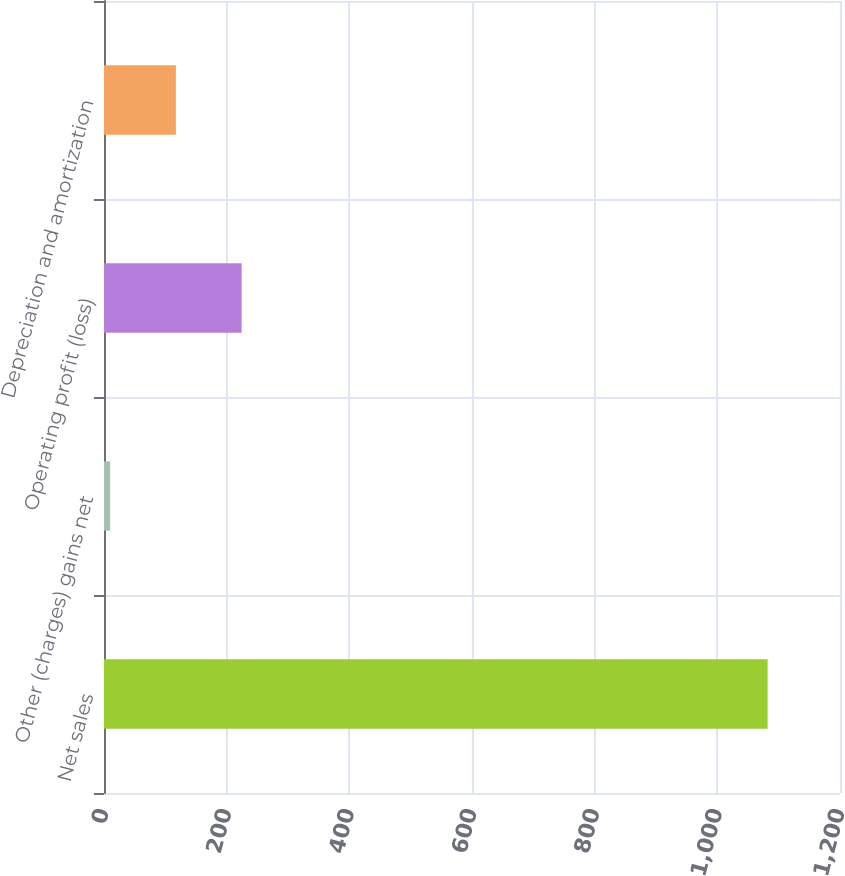Convert chart. <chart><loc_0><loc_0><loc_500><loc_500><bar_chart><fcel>Net sales<fcel>Other (charges) gains net<fcel>Operating profit (loss)<fcel>Depreciation and amortization<nl><fcel>1082<fcel>10<fcel>224.4<fcel>117.2<nl></chart> 